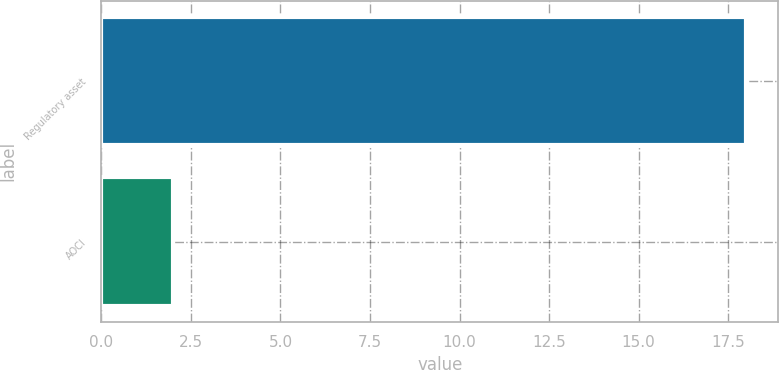Convert chart to OTSL. <chart><loc_0><loc_0><loc_500><loc_500><bar_chart><fcel>Regulatory asset<fcel>AOCI<nl><fcel>18<fcel>2<nl></chart> 